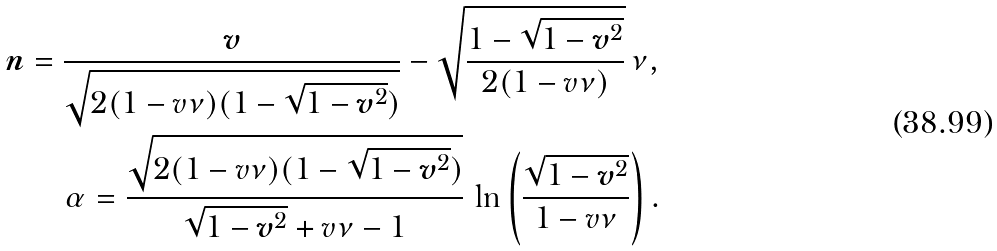<formula> <loc_0><loc_0><loc_500><loc_500>\boldsymbol n = \frac { \boldsymbol v } { \sqrt { 2 ( 1 - v \nu ) ( 1 - \sqrt { 1 - { \boldsymbol v } ^ { 2 } } ) } } - \sqrt { \frac { 1 - \sqrt { 1 - { \boldsymbol v } ^ { 2 } } } { 2 ( 1 - v \nu ) } } \, \nu , \\ \alpha = \frac { \sqrt { 2 ( 1 - v \nu ) ( 1 - \sqrt { 1 - { \boldsymbol v } ^ { 2 } } ) } } { \sqrt { 1 - { \boldsymbol v } ^ { 2 } } + v \nu - 1 } \, \ln \left ( \frac { \sqrt { 1 - { \boldsymbol v } ^ { 2 } } } { 1 - v \nu } \right ) .</formula> 